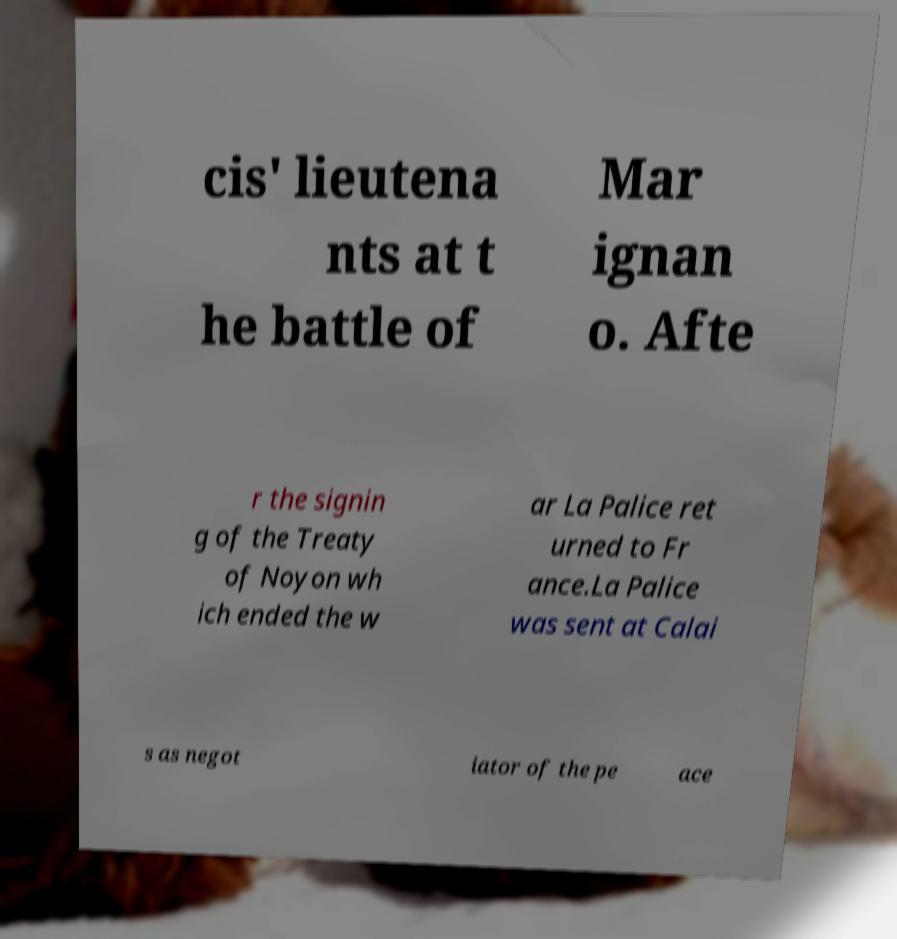Can you accurately transcribe the text from the provided image for me? cis' lieutena nts at t he battle of Mar ignan o. Afte r the signin g of the Treaty of Noyon wh ich ended the w ar La Palice ret urned to Fr ance.La Palice was sent at Calai s as negot iator of the pe ace 